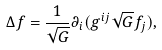<formula> <loc_0><loc_0><loc_500><loc_500>\Delta f = \frac { 1 } { \sqrt { G } } \partial _ { i } ( g ^ { i j } \sqrt { G } f _ { j } ) ,</formula> 